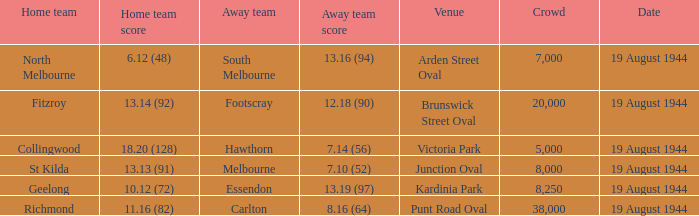What is the size of fitzroy's home team audience? 20000.0. 